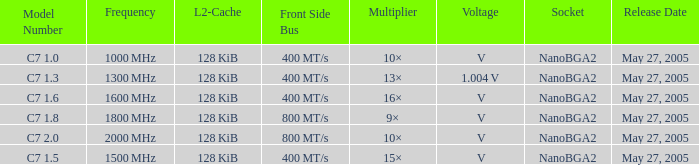What is the Release Date for Model Number c7 1.8? May 27, 2005. 